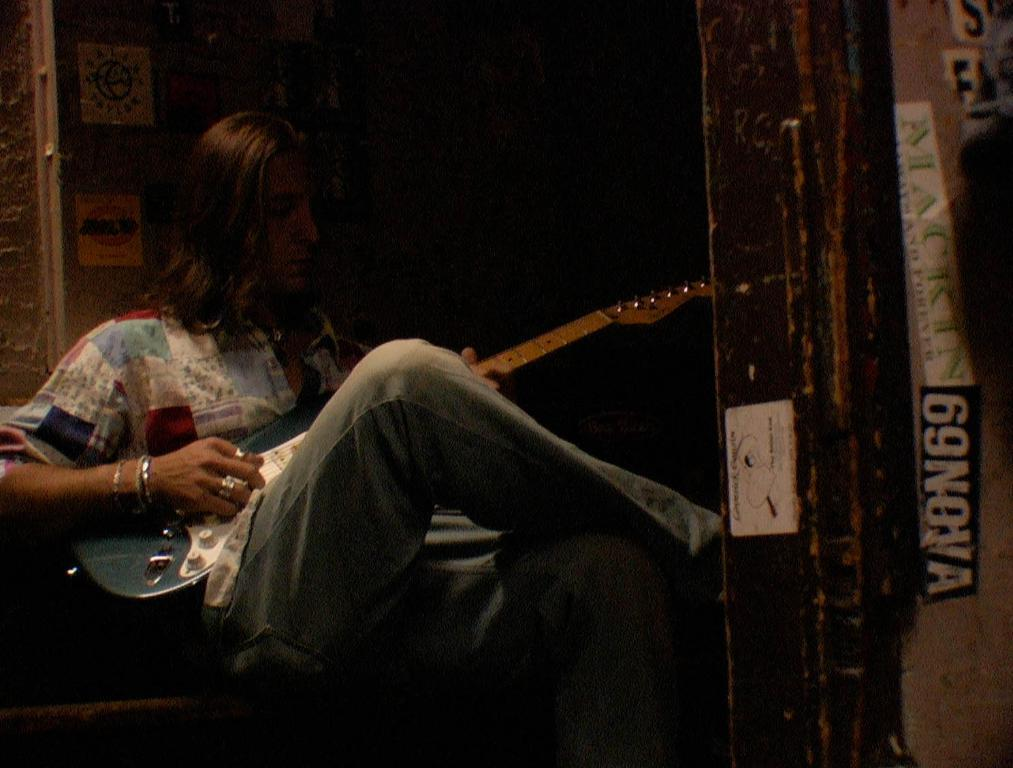<image>
Write a terse but informative summary of the picture. A long-haired man playing an electric guitar while seated in an open doorway with a sticker that says 69 NOVA on the wall. 